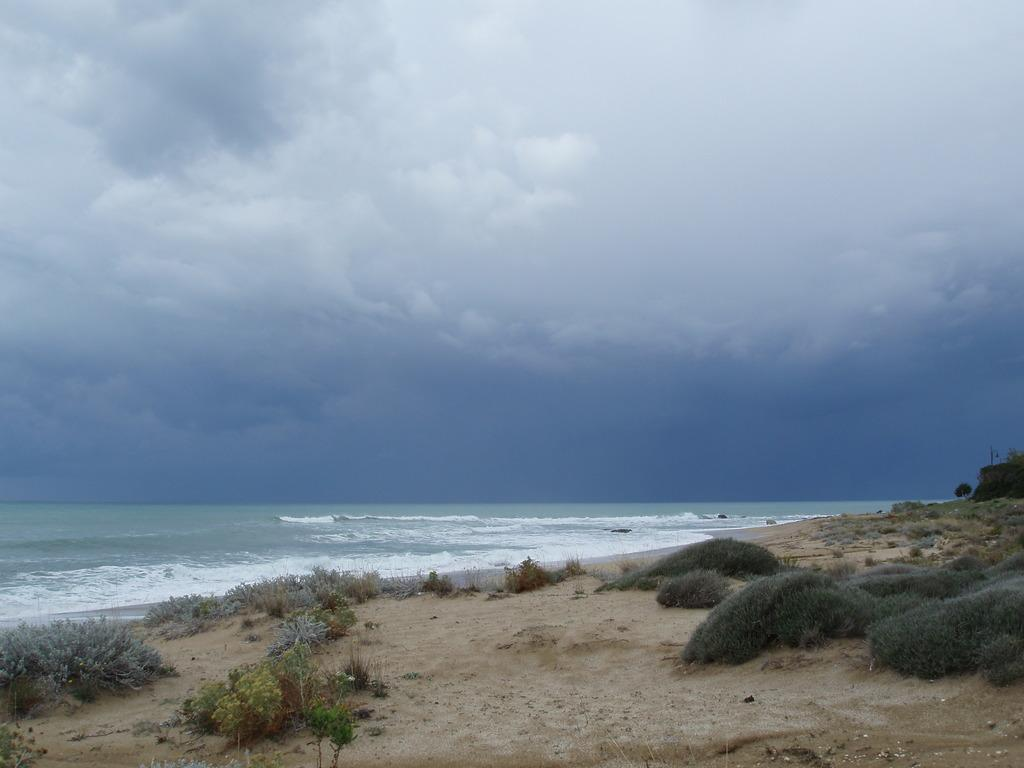What type of vegetation is present on the ground in the image? There is grass and plants on the ground in the image. What can be seen in the background of the image? There is water visible in the background of the image. What is visible in the sky in the image? There are clouds in the sky in the image. Can you hear the airport in the background of the image? There is no airport present in the image, and therefore no sound can be heard from it. What type of wax is used to create the clouds in the image? The clouds in the image are natural formations in the sky and are not created using wax. 